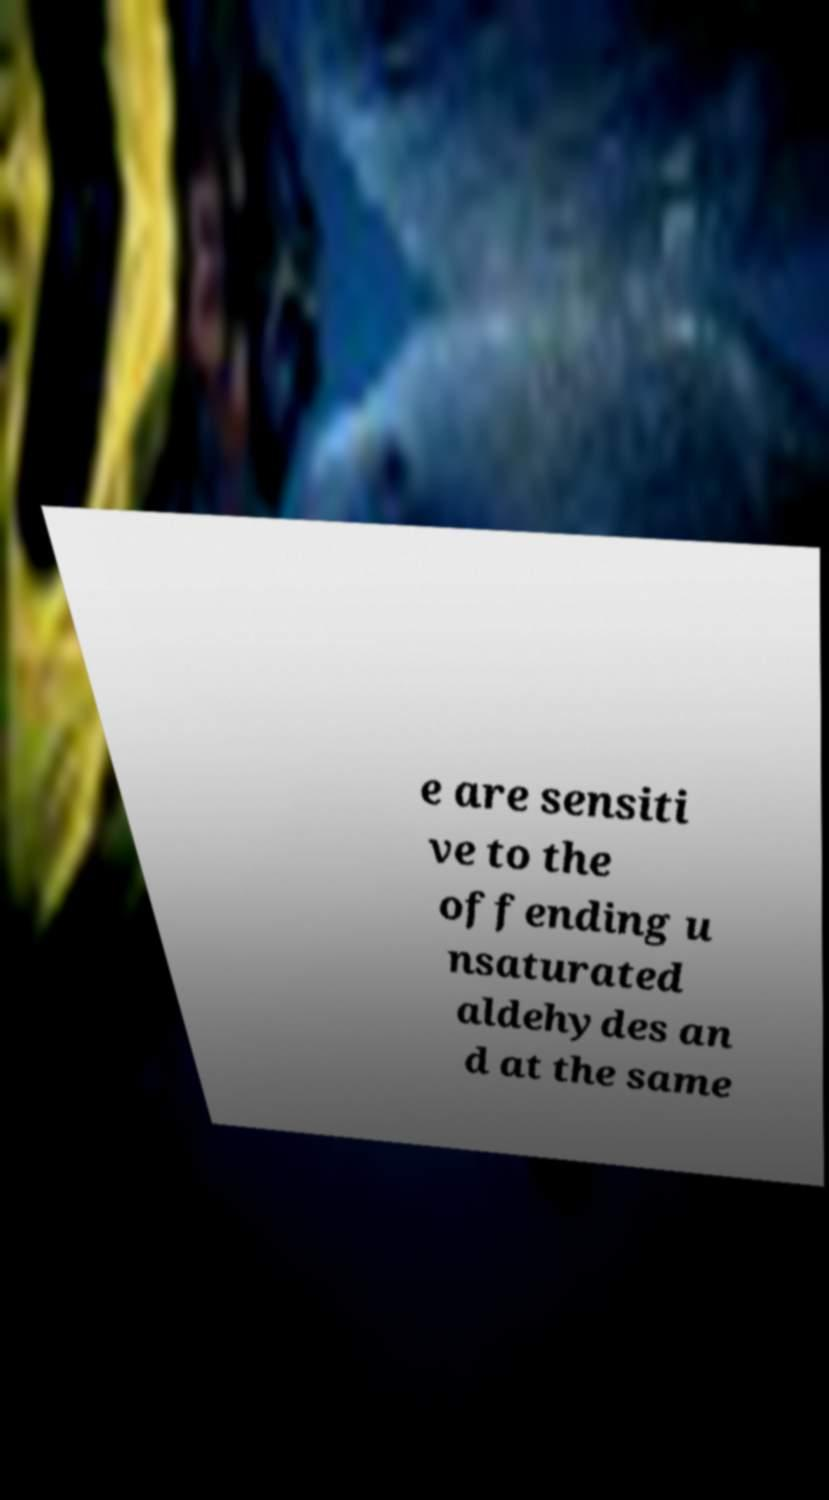Can you read and provide the text displayed in the image?This photo seems to have some interesting text. Can you extract and type it out for me? e are sensiti ve to the offending u nsaturated aldehydes an d at the same 